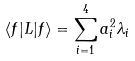<formula> <loc_0><loc_0><loc_500><loc_500>\langle f | L | f \rangle = \sum _ { i = 1 } ^ { 4 } a _ { i } ^ { 2 } \lambda _ { i }</formula> 